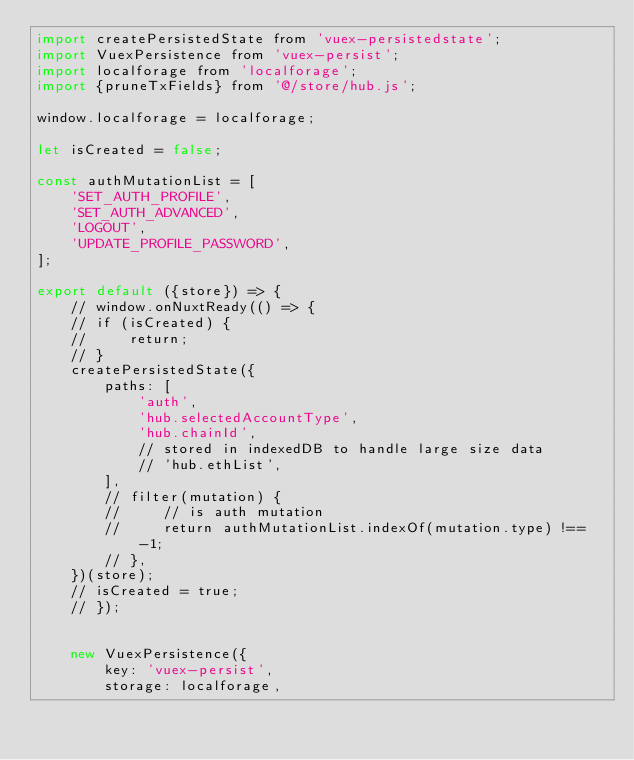Convert code to text. <code><loc_0><loc_0><loc_500><loc_500><_JavaScript_>import createPersistedState from 'vuex-persistedstate';
import VuexPersistence from 'vuex-persist';
import localforage from 'localforage';
import {pruneTxFields} from '@/store/hub.js';

window.localforage = localforage;

let isCreated = false;

const authMutationList = [
    'SET_AUTH_PROFILE',
    'SET_AUTH_ADVANCED',
    'LOGOUT',
    'UPDATE_PROFILE_PASSWORD',
];

export default ({store}) => {
    // window.onNuxtReady(() => {
    // if (isCreated) {
    //     return;
    // }
    createPersistedState({
        paths: [
            'auth',
            'hub.selectedAccountType',
            'hub.chainId',
            // stored in indexedDB to handle large size data
            // 'hub.ethList',
        ],
        // filter(mutation) {
        //     // is auth mutation
        //     return authMutationList.indexOf(mutation.type) !== -1;
        // },
    })(store);
    // isCreated = true;
    // });


    new VuexPersistence({
        key: 'vuex-persist',
        storage: localforage,</code> 